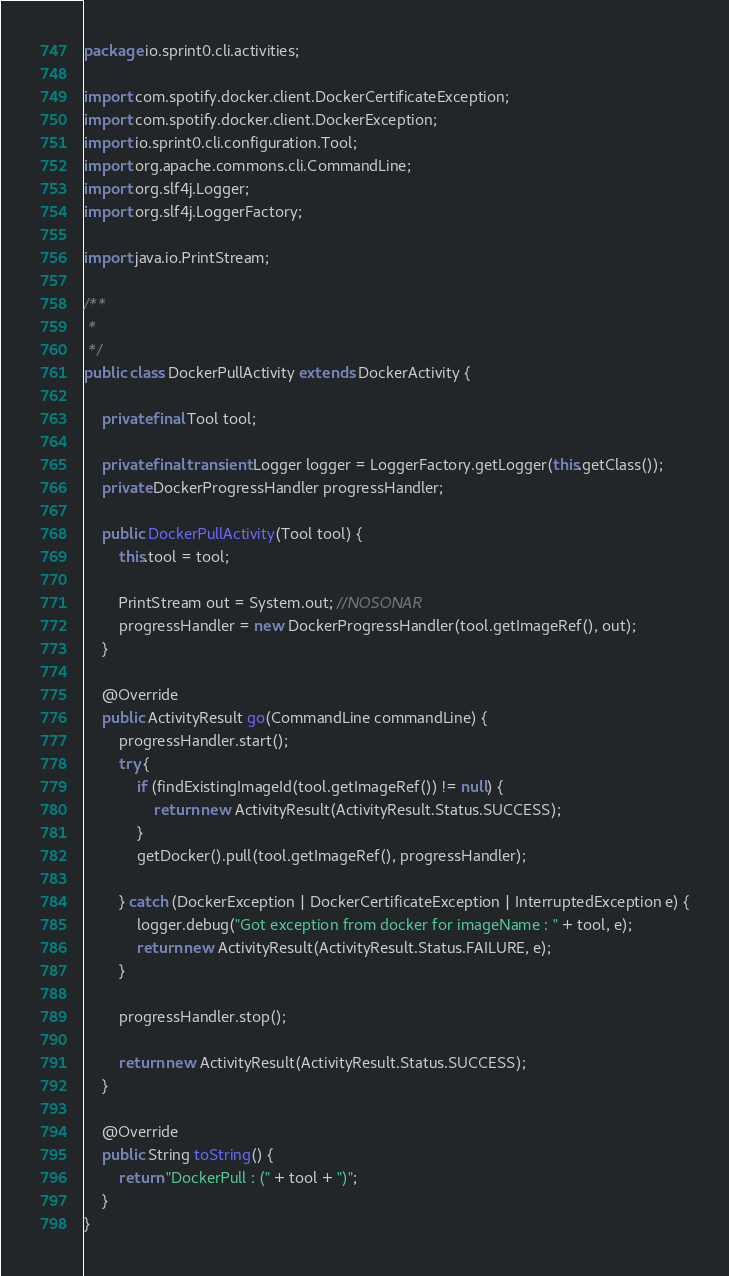<code> <loc_0><loc_0><loc_500><loc_500><_Java_>package io.sprint0.cli.activities;

import com.spotify.docker.client.DockerCertificateException;
import com.spotify.docker.client.DockerException;
import io.sprint0.cli.configuration.Tool;
import org.apache.commons.cli.CommandLine;
import org.slf4j.Logger;
import org.slf4j.LoggerFactory;

import java.io.PrintStream;

/**
 *
 */
public class DockerPullActivity extends DockerActivity {

    private final Tool tool;

    private final transient Logger logger = LoggerFactory.getLogger(this.getClass());
    private DockerProgressHandler progressHandler;

    public DockerPullActivity(Tool tool) {
        this.tool = tool;

        PrintStream out = System.out; //NOSONAR
        progressHandler = new DockerProgressHandler(tool.getImageRef(), out);
    }

    @Override
    public ActivityResult go(CommandLine commandLine) {
        progressHandler.start();
        try {
            if (findExistingImageId(tool.getImageRef()) != null) {
                return new ActivityResult(ActivityResult.Status.SUCCESS);
            }
            getDocker().pull(tool.getImageRef(), progressHandler);

        } catch (DockerException | DockerCertificateException | InterruptedException e) {
            logger.debug("Got exception from docker for imageName : " + tool, e);
            return new ActivityResult(ActivityResult.Status.FAILURE, e);
        }

        progressHandler.stop();

        return new ActivityResult(ActivityResult.Status.SUCCESS);
    }

    @Override
    public String toString() {
        return "DockerPull : (" + tool + ")";
    }
}
</code> 